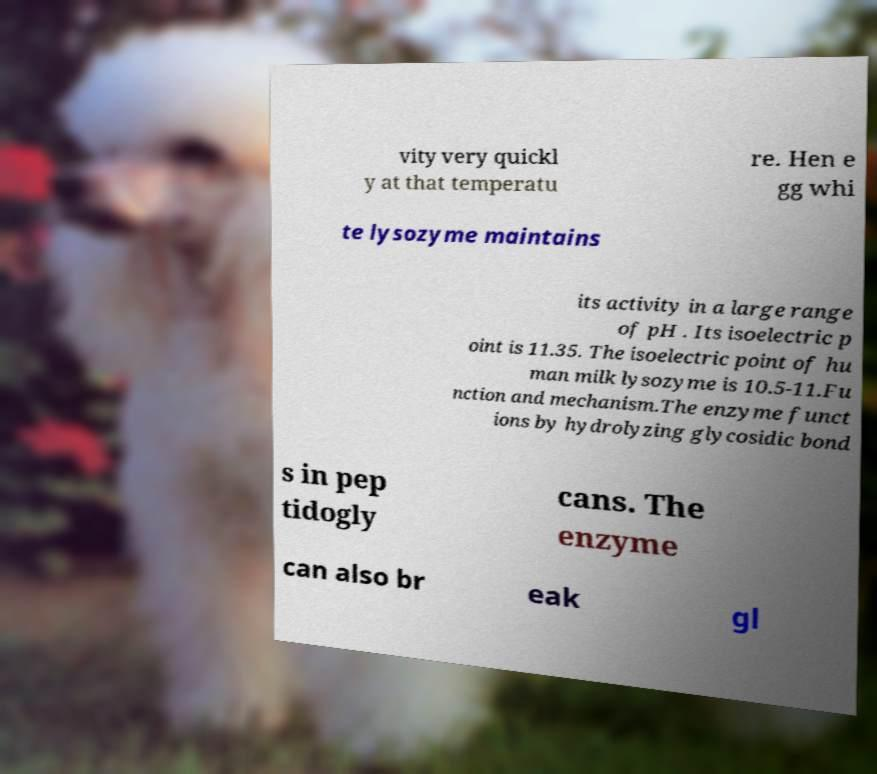Please identify and transcribe the text found in this image. vity very quickl y at that temperatu re. Hen e gg whi te lysozyme maintains its activity in a large range of pH . Its isoelectric p oint is 11.35. The isoelectric point of hu man milk lysozyme is 10.5-11.Fu nction and mechanism.The enzyme funct ions by hydrolyzing glycosidic bond s in pep tidogly cans. The enzyme can also br eak gl 